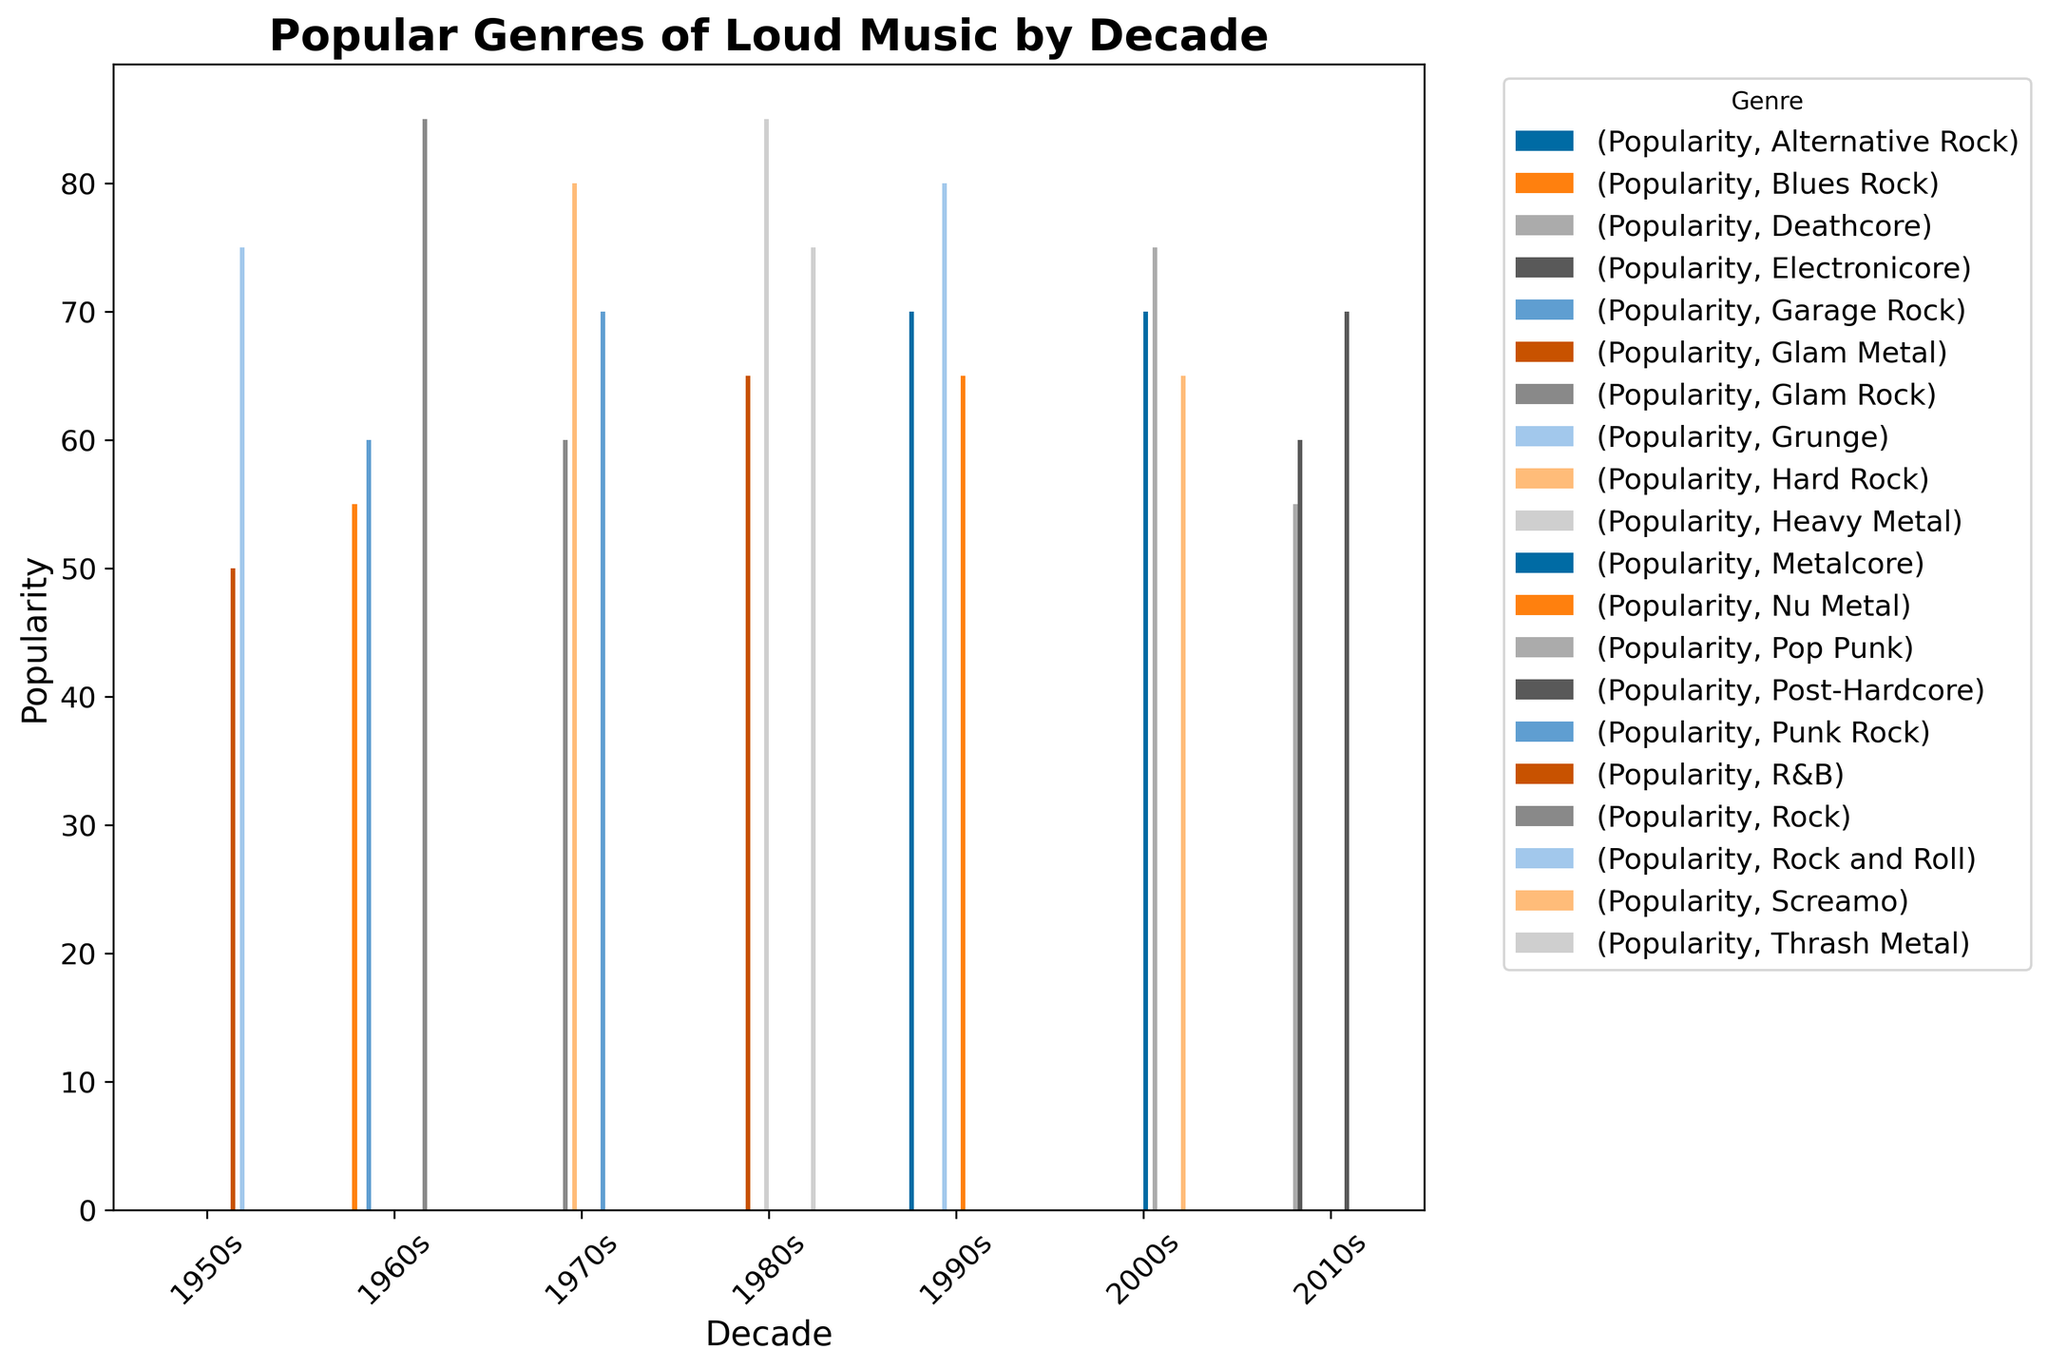Which genre was the most popular in the 1960s? The bar chart shows the popularity of different genres in the 1960s. The bar for Rock is the highest among them.
Answer: Rock Which genre saw a similar level of popularity in the 1970s and the 2000s? In the 1970s, Punk Rock had a popularity score of 70, and in the 2000s, Metalcore also had a popularity score of 70.
Answer: Punk Rock and Metalcore Which decade had the highest diversity in popular genres based on the number of different genres shown? By counting the bars for each decade, the 1960s and the 1980s both show three different genres, while the other decades have fewer.
Answer: 1960s and 1980s How does the popularity of Heavy Metal in the 1980s compare to the popularity of Grunge in the 1990s? The bar for Heavy Metal in the 1980s and Grunge in the 1990s each are at the 85 mark, showing they have equal popularity.
Answer: Equal What is the total popularity score for genres in the 2000s? Adding the popularity scores of Pop Punk (75), Metalcore (70), and Screamo (65) yields a total of 210.
Answer: 210 Which genre had the least popularity in the 2010s, and what was its popularity score? The bar chart shows that Deathcore has the smallest height among the genres in the 2010s, with a score of 55.
Answer: Deathcore, 55 Compare the popularity of Rock in the 1960s with that of Hard Rock in the 1970s. Rock in the 1960s has a popularity score of 85, while Hard Rock in the 1970s has a score of 80. Therefore, Rock in the 1960s is slightly more popular.
Answer: Rock in the 1960s What is the difference in popularity scores between R&B in the 1950s and Thrash Metal in the 1980s? R&B in the 1950s has a score of 50, and Thrash Metal in the 1980s has a score of 75. The difference is 75 - 50 = 25.
Answer: 25 Which genre experienced an increase in popularity from the 1970s to the 1980s? Comparing the bars for the same genres in both decades, Glam Rock in the 1970s had a score of 60, while Glam Metal (although a variation) in the 1980s had a score of 65, indicating an increase.
Answer: Glam Rock to Glam Metal 